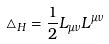Convert formula to latex. <formula><loc_0><loc_0><loc_500><loc_500>\triangle _ { H } = \frac { 1 } { 2 } L _ { \mu \nu } L ^ { \mu \nu }</formula> 